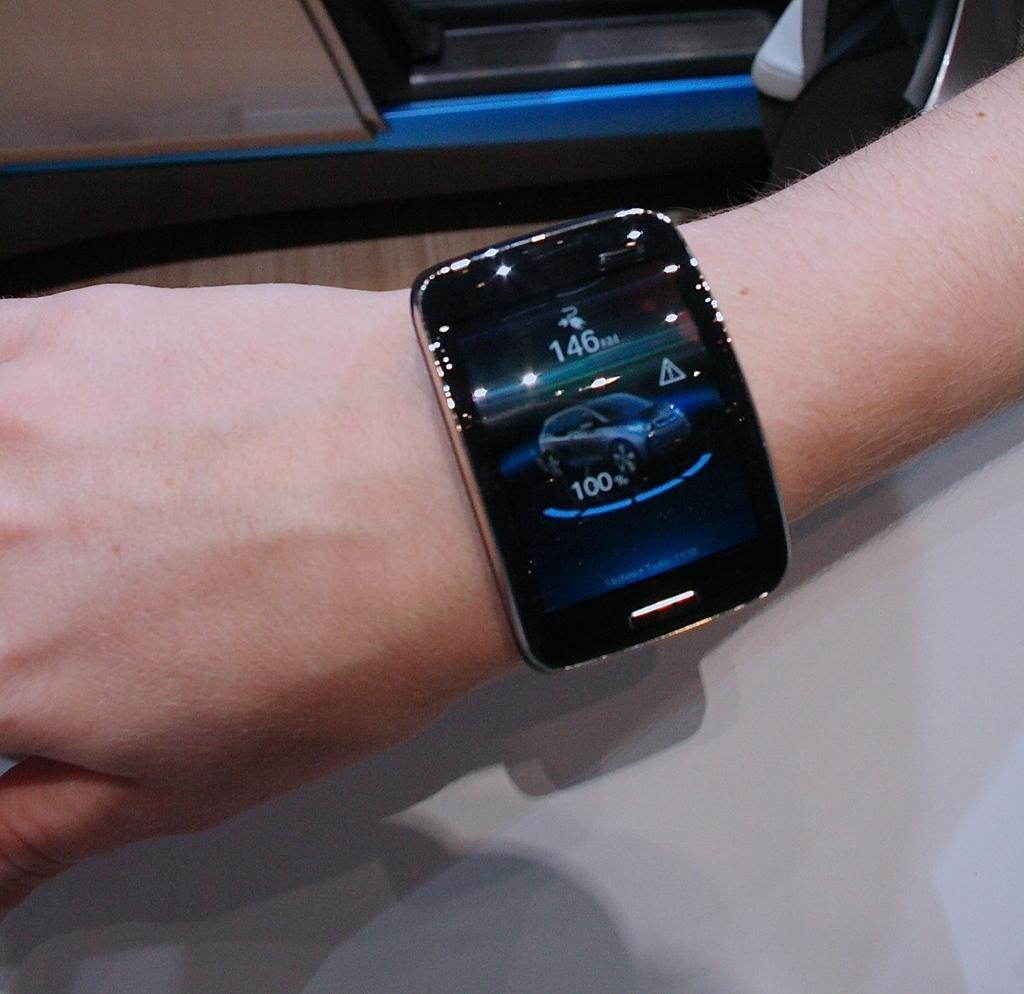<image>
Summarize the visual content of the image. A large display watch on someone's wrist with the number 146 at the top. 